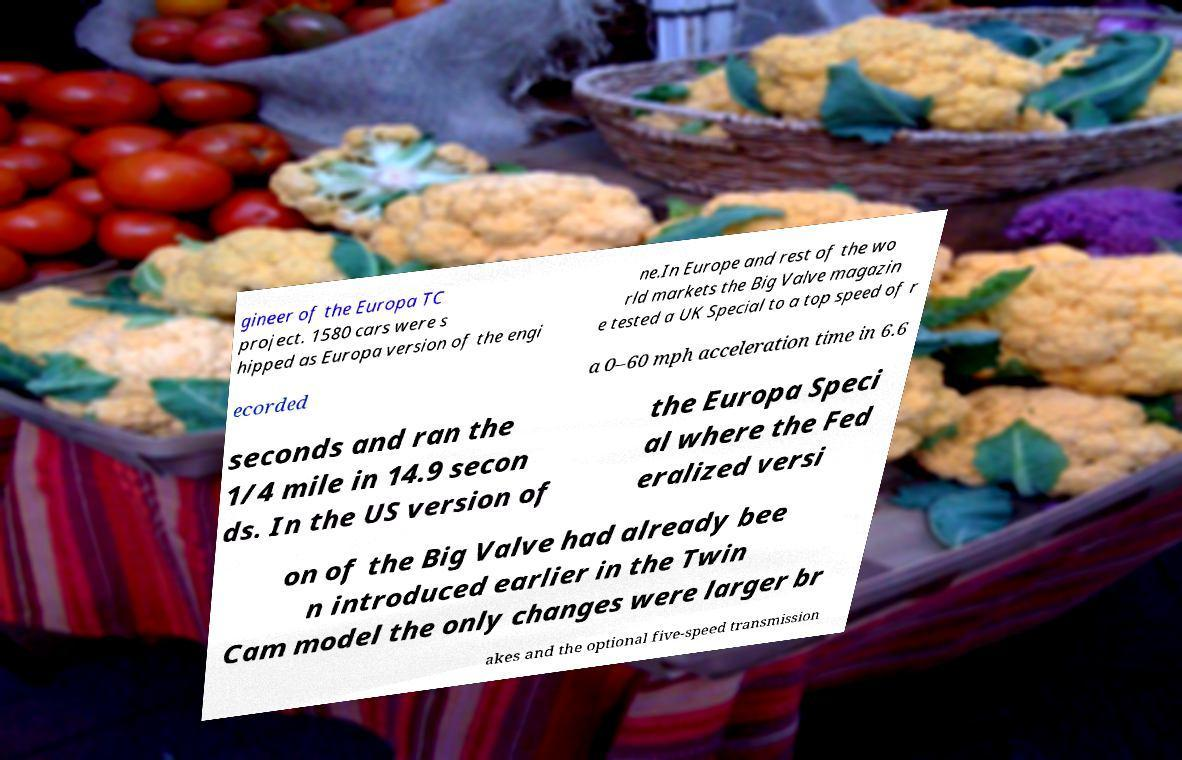Could you assist in decoding the text presented in this image and type it out clearly? gineer of the Europa TC project. 1580 cars were s hipped as Europa version of the engi ne.In Europe and rest of the wo rld markets the Big Valve magazin e tested a UK Special to a top speed of r ecorded a 0–60 mph acceleration time in 6.6 seconds and ran the 1/4 mile in 14.9 secon ds. In the US version of the Europa Speci al where the Fed eralized versi on of the Big Valve had already bee n introduced earlier in the Twin Cam model the only changes were larger br akes and the optional five-speed transmission 